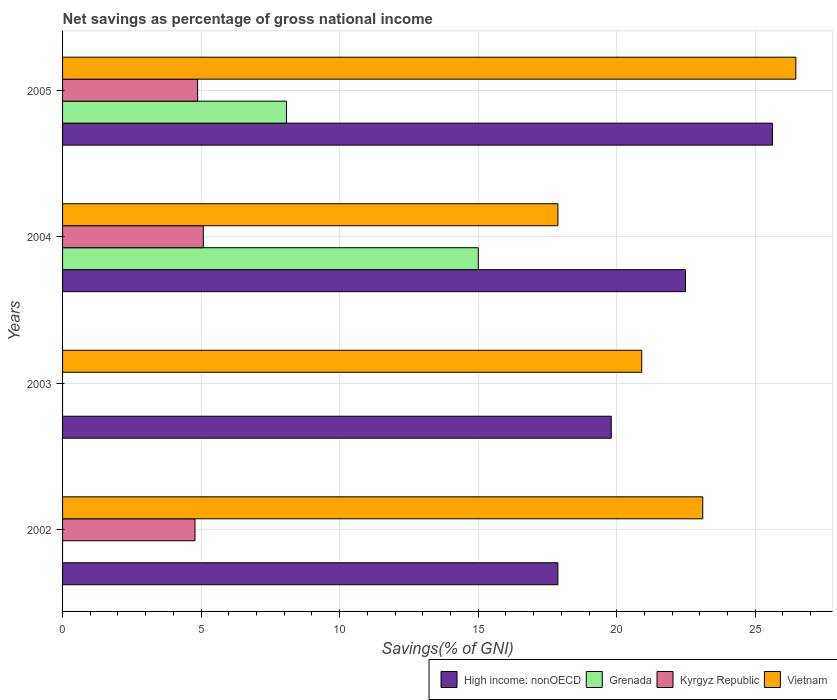How many different coloured bars are there?
Offer a terse response. 4. Are the number of bars on each tick of the Y-axis equal?
Make the answer very short. No. How many bars are there on the 3rd tick from the top?
Ensure brevity in your answer.  2. What is the label of the 1st group of bars from the top?
Offer a very short reply. 2005. What is the total savings in Kyrgyz Republic in 2002?
Provide a short and direct response. 4.78. Across all years, what is the maximum total savings in Vietnam?
Offer a very short reply. 26.46. Across all years, what is the minimum total savings in Vietnam?
Offer a terse response. 17.88. What is the total total savings in High income: nonOECD in the graph?
Give a very brief answer. 85.78. What is the difference between the total savings in Vietnam in 2002 and that in 2004?
Provide a short and direct response. 5.23. What is the difference between the total savings in Kyrgyz Republic in 2003 and the total savings in Grenada in 2002?
Provide a short and direct response. 0. What is the average total savings in Kyrgyz Republic per year?
Ensure brevity in your answer.  3.68. In the year 2002, what is the difference between the total savings in High income: nonOECD and total savings in Vietnam?
Ensure brevity in your answer.  -5.23. What is the ratio of the total savings in Kyrgyz Republic in 2002 to that in 2004?
Make the answer very short. 0.94. Is the total savings in High income: nonOECD in 2002 less than that in 2004?
Make the answer very short. Yes. What is the difference between the highest and the second highest total savings in Kyrgyz Republic?
Keep it short and to the point. 0.2. What is the difference between the highest and the lowest total savings in High income: nonOECD?
Provide a succinct answer. 7.74. Is the sum of the total savings in High income: nonOECD in 2003 and 2005 greater than the maximum total savings in Grenada across all years?
Offer a terse response. Yes. What is the difference between two consecutive major ticks on the X-axis?
Offer a terse response. 5. Are the values on the major ticks of X-axis written in scientific E-notation?
Provide a succinct answer. No. Does the graph contain any zero values?
Offer a terse response. Yes. How many legend labels are there?
Provide a short and direct response. 4. What is the title of the graph?
Offer a very short reply. Net savings as percentage of gross national income. What is the label or title of the X-axis?
Your response must be concise. Savings(% of GNI). What is the Savings(% of GNI) in High income: nonOECD in 2002?
Provide a succinct answer. 17.88. What is the Savings(% of GNI) of Grenada in 2002?
Your answer should be compact. 0. What is the Savings(% of GNI) in Kyrgyz Republic in 2002?
Offer a very short reply. 4.78. What is the Savings(% of GNI) in Vietnam in 2002?
Provide a short and direct response. 23.11. What is the Savings(% of GNI) of High income: nonOECD in 2003?
Provide a short and direct response. 19.8. What is the Savings(% of GNI) of Kyrgyz Republic in 2003?
Your answer should be compact. 0. What is the Savings(% of GNI) in Vietnam in 2003?
Offer a very short reply. 20.9. What is the Savings(% of GNI) in High income: nonOECD in 2004?
Give a very brief answer. 22.48. What is the Savings(% of GNI) in Grenada in 2004?
Keep it short and to the point. 15. What is the Savings(% of GNI) of Kyrgyz Republic in 2004?
Offer a very short reply. 5.08. What is the Savings(% of GNI) in Vietnam in 2004?
Ensure brevity in your answer.  17.88. What is the Savings(% of GNI) of High income: nonOECD in 2005?
Offer a terse response. 25.62. What is the Savings(% of GNI) in Grenada in 2005?
Ensure brevity in your answer.  8.08. What is the Savings(% of GNI) in Kyrgyz Republic in 2005?
Keep it short and to the point. 4.88. What is the Savings(% of GNI) of Vietnam in 2005?
Offer a terse response. 26.46. Across all years, what is the maximum Savings(% of GNI) of High income: nonOECD?
Offer a terse response. 25.62. Across all years, what is the maximum Savings(% of GNI) of Grenada?
Your answer should be very brief. 15. Across all years, what is the maximum Savings(% of GNI) of Kyrgyz Republic?
Keep it short and to the point. 5.08. Across all years, what is the maximum Savings(% of GNI) in Vietnam?
Your response must be concise. 26.46. Across all years, what is the minimum Savings(% of GNI) of High income: nonOECD?
Your answer should be compact. 17.88. Across all years, what is the minimum Savings(% of GNI) in Kyrgyz Republic?
Provide a short and direct response. 0. Across all years, what is the minimum Savings(% of GNI) in Vietnam?
Your answer should be very brief. 17.88. What is the total Savings(% of GNI) of High income: nonOECD in the graph?
Your answer should be compact. 85.78. What is the total Savings(% of GNI) of Grenada in the graph?
Provide a short and direct response. 23.09. What is the total Savings(% of GNI) in Kyrgyz Republic in the graph?
Make the answer very short. 14.73. What is the total Savings(% of GNI) of Vietnam in the graph?
Your answer should be very brief. 88.35. What is the difference between the Savings(% of GNI) in High income: nonOECD in 2002 and that in 2003?
Your answer should be compact. -1.93. What is the difference between the Savings(% of GNI) in Vietnam in 2002 and that in 2003?
Give a very brief answer. 2.2. What is the difference between the Savings(% of GNI) in High income: nonOECD in 2002 and that in 2004?
Your response must be concise. -4.6. What is the difference between the Savings(% of GNI) of Kyrgyz Republic in 2002 and that in 2004?
Offer a very short reply. -0.3. What is the difference between the Savings(% of GNI) of Vietnam in 2002 and that in 2004?
Your answer should be compact. 5.23. What is the difference between the Savings(% of GNI) of High income: nonOECD in 2002 and that in 2005?
Offer a very short reply. -7.74. What is the difference between the Savings(% of GNI) in Kyrgyz Republic in 2002 and that in 2005?
Your answer should be very brief. -0.1. What is the difference between the Savings(% of GNI) of Vietnam in 2002 and that in 2005?
Your answer should be compact. -3.36. What is the difference between the Savings(% of GNI) in High income: nonOECD in 2003 and that in 2004?
Make the answer very short. -2.68. What is the difference between the Savings(% of GNI) in Vietnam in 2003 and that in 2004?
Your response must be concise. 3.03. What is the difference between the Savings(% of GNI) in High income: nonOECD in 2003 and that in 2005?
Offer a very short reply. -5.82. What is the difference between the Savings(% of GNI) of Vietnam in 2003 and that in 2005?
Give a very brief answer. -5.56. What is the difference between the Savings(% of GNI) of High income: nonOECD in 2004 and that in 2005?
Offer a terse response. -3.14. What is the difference between the Savings(% of GNI) in Grenada in 2004 and that in 2005?
Provide a short and direct response. 6.92. What is the difference between the Savings(% of GNI) in Kyrgyz Republic in 2004 and that in 2005?
Make the answer very short. 0.2. What is the difference between the Savings(% of GNI) of Vietnam in 2004 and that in 2005?
Offer a terse response. -8.59. What is the difference between the Savings(% of GNI) of High income: nonOECD in 2002 and the Savings(% of GNI) of Vietnam in 2003?
Your answer should be very brief. -3.03. What is the difference between the Savings(% of GNI) in Kyrgyz Republic in 2002 and the Savings(% of GNI) in Vietnam in 2003?
Keep it short and to the point. -16.12. What is the difference between the Savings(% of GNI) in High income: nonOECD in 2002 and the Savings(% of GNI) in Grenada in 2004?
Ensure brevity in your answer.  2.87. What is the difference between the Savings(% of GNI) of High income: nonOECD in 2002 and the Savings(% of GNI) of Kyrgyz Republic in 2004?
Make the answer very short. 12.8. What is the difference between the Savings(% of GNI) in High income: nonOECD in 2002 and the Savings(% of GNI) in Vietnam in 2004?
Provide a succinct answer. -0. What is the difference between the Savings(% of GNI) in Kyrgyz Republic in 2002 and the Savings(% of GNI) in Vietnam in 2004?
Keep it short and to the point. -13.1. What is the difference between the Savings(% of GNI) of High income: nonOECD in 2002 and the Savings(% of GNI) of Grenada in 2005?
Make the answer very short. 9.8. What is the difference between the Savings(% of GNI) in High income: nonOECD in 2002 and the Savings(% of GNI) in Kyrgyz Republic in 2005?
Your response must be concise. 13. What is the difference between the Savings(% of GNI) in High income: nonOECD in 2002 and the Savings(% of GNI) in Vietnam in 2005?
Offer a terse response. -8.59. What is the difference between the Savings(% of GNI) in Kyrgyz Republic in 2002 and the Savings(% of GNI) in Vietnam in 2005?
Ensure brevity in your answer.  -21.68. What is the difference between the Savings(% of GNI) in High income: nonOECD in 2003 and the Savings(% of GNI) in Grenada in 2004?
Your answer should be very brief. 4.8. What is the difference between the Savings(% of GNI) of High income: nonOECD in 2003 and the Savings(% of GNI) of Kyrgyz Republic in 2004?
Give a very brief answer. 14.72. What is the difference between the Savings(% of GNI) in High income: nonOECD in 2003 and the Savings(% of GNI) in Vietnam in 2004?
Your answer should be very brief. 1.93. What is the difference between the Savings(% of GNI) in High income: nonOECD in 2003 and the Savings(% of GNI) in Grenada in 2005?
Offer a very short reply. 11.72. What is the difference between the Savings(% of GNI) in High income: nonOECD in 2003 and the Savings(% of GNI) in Kyrgyz Republic in 2005?
Give a very brief answer. 14.93. What is the difference between the Savings(% of GNI) of High income: nonOECD in 2003 and the Savings(% of GNI) of Vietnam in 2005?
Your response must be concise. -6.66. What is the difference between the Savings(% of GNI) in High income: nonOECD in 2004 and the Savings(% of GNI) in Grenada in 2005?
Provide a short and direct response. 14.4. What is the difference between the Savings(% of GNI) in High income: nonOECD in 2004 and the Savings(% of GNI) in Kyrgyz Republic in 2005?
Your answer should be very brief. 17.61. What is the difference between the Savings(% of GNI) in High income: nonOECD in 2004 and the Savings(% of GNI) in Vietnam in 2005?
Provide a succinct answer. -3.98. What is the difference between the Savings(% of GNI) in Grenada in 2004 and the Savings(% of GNI) in Kyrgyz Republic in 2005?
Ensure brevity in your answer.  10.13. What is the difference between the Savings(% of GNI) in Grenada in 2004 and the Savings(% of GNI) in Vietnam in 2005?
Your answer should be compact. -11.46. What is the difference between the Savings(% of GNI) in Kyrgyz Republic in 2004 and the Savings(% of GNI) in Vietnam in 2005?
Your response must be concise. -21.39. What is the average Savings(% of GNI) of High income: nonOECD per year?
Offer a very short reply. 21.45. What is the average Savings(% of GNI) in Grenada per year?
Your answer should be very brief. 5.77. What is the average Savings(% of GNI) in Kyrgyz Republic per year?
Ensure brevity in your answer.  3.68. What is the average Savings(% of GNI) of Vietnam per year?
Offer a terse response. 22.09. In the year 2002, what is the difference between the Savings(% of GNI) of High income: nonOECD and Savings(% of GNI) of Kyrgyz Republic?
Your answer should be compact. 13.1. In the year 2002, what is the difference between the Savings(% of GNI) in High income: nonOECD and Savings(% of GNI) in Vietnam?
Give a very brief answer. -5.23. In the year 2002, what is the difference between the Savings(% of GNI) in Kyrgyz Republic and Savings(% of GNI) in Vietnam?
Offer a terse response. -18.33. In the year 2003, what is the difference between the Savings(% of GNI) in High income: nonOECD and Savings(% of GNI) in Vietnam?
Offer a very short reply. -1.1. In the year 2004, what is the difference between the Savings(% of GNI) of High income: nonOECD and Savings(% of GNI) of Grenada?
Give a very brief answer. 7.48. In the year 2004, what is the difference between the Savings(% of GNI) in High income: nonOECD and Savings(% of GNI) in Kyrgyz Republic?
Provide a succinct answer. 17.4. In the year 2004, what is the difference between the Savings(% of GNI) in High income: nonOECD and Savings(% of GNI) in Vietnam?
Offer a terse response. 4.6. In the year 2004, what is the difference between the Savings(% of GNI) in Grenada and Savings(% of GNI) in Kyrgyz Republic?
Your response must be concise. 9.93. In the year 2004, what is the difference between the Savings(% of GNI) in Grenada and Savings(% of GNI) in Vietnam?
Keep it short and to the point. -2.87. In the year 2004, what is the difference between the Savings(% of GNI) of Kyrgyz Republic and Savings(% of GNI) of Vietnam?
Your answer should be very brief. -12.8. In the year 2005, what is the difference between the Savings(% of GNI) in High income: nonOECD and Savings(% of GNI) in Grenada?
Provide a succinct answer. 17.54. In the year 2005, what is the difference between the Savings(% of GNI) of High income: nonOECD and Savings(% of GNI) of Kyrgyz Republic?
Provide a succinct answer. 20.75. In the year 2005, what is the difference between the Savings(% of GNI) of High income: nonOECD and Savings(% of GNI) of Vietnam?
Your response must be concise. -0.84. In the year 2005, what is the difference between the Savings(% of GNI) in Grenada and Savings(% of GNI) in Kyrgyz Republic?
Keep it short and to the point. 3.21. In the year 2005, what is the difference between the Savings(% of GNI) in Grenada and Savings(% of GNI) in Vietnam?
Provide a short and direct response. -18.38. In the year 2005, what is the difference between the Savings(% of GNI) of Kyrgyz Republic and Savings(% of GNI) of Vietnam?
Offer a very short reply. -21.59. What is the ratio of the Savings(% of GNI) of High income: nonOECD in 2002 to that in 2003?
Your answer should be very brief. 0.9. What is the ratio of the Savings(% of GNI) in Vietnam in 2002 to that in 2003?
Provide a succinct answer. 1.11. What is the ratio of the Savings(% of GNI) of High income: nonOECD in 2002 to that in 2004?
Give a very brief answer. 0.8. What is the ratio of the Savings(% of GNI) of Kyrgyz Republic in 2002 to that in 2004?
Ensure brevity in your answer.  0.94. What is the ratio of the Savings(% of GNI) in Vietnam in 2002 to that in 2004?
Ensure brevity in your answer.  1.29. What is the ratio of the Savings(% of GNI) of High income: nonOECD in 2002 to that in 2005?
Ensure brevity in your answer.  0.7. What is the ratio of the Savings(% of GNI) of Kyrgyz Republic in 2002 to that in 2005?
Provide a short and direct response. 0.98. What is the ratio of the Savings(% of GNI) of Vietnam in 2002 to that in 2005?
Your answer should be compact. 0.87. What is the ratio of the Savings(% of GNI) in High income: nonOECD in 2003 to that in 2004?
Give a very brief answer. 0.88. What is the ratio of the Savings(% of GNI) of Vietnam in 2003 to that in 2004?
Make the answer very short. 1.17. What is the ratio of the Savings(% of GNI) of High income: nonOECD in 2003 to that in 2005?
Keep it short and to the point. 0.77. What is the ratio of the Savings(% of GNI) in Vietnam in 2003 to that in 2005?
Your answer should be very brief. 0.79. What is the ratio of the Savings(% of GNI) of High income: nonOECD in 2004 to that in 2005?
Ensure brevity in your answer.  0.88. What is the ratio of the Savings(% of GNI) in Grenada in 2004 to that in 2005?
Give a very brief answer. 1.86. What is the ratio of the Savings(% of GNI) of Kyrgyz Republic in 2004 to that in 2005?
Keep it short and to the point. 1.04. What is the ratio of the Savings(% of GNI) in Vietnam in 2004 to that in 2005?
Offer a very short reply. 0.68. What is the difference between the highest and the second highest Savings(% of GNI) of High income: nonOECD?
Your answer should be compact. 3.14. What is the difference between the highest and the second highest Savings(% of GNI) of Kyrgyz Republic?
Give a very brief answer. 0.2. What is the difference between the highest and the second highest Savings(% of GNI) in Vietnam?
Provide a short and direct response. 3.36. What is the difference between the highest and the lowest Savings(% of GNI) of High income: nonOECD?
Offer a very short reply. 7.74. What is the difference between the highest and the lowest Savings(% of GNI) of Grenada?
Your answer should be compact. 15. What is the difference between the highest and the lowest Savings(% of GNI) of Kyrgyz Republic?
Ensure brevity in your answer.  5.08. What is the difference between the highest and the lowest Savings(% of GNI) in Vietnam?
Your response must be concise. 8.59. 